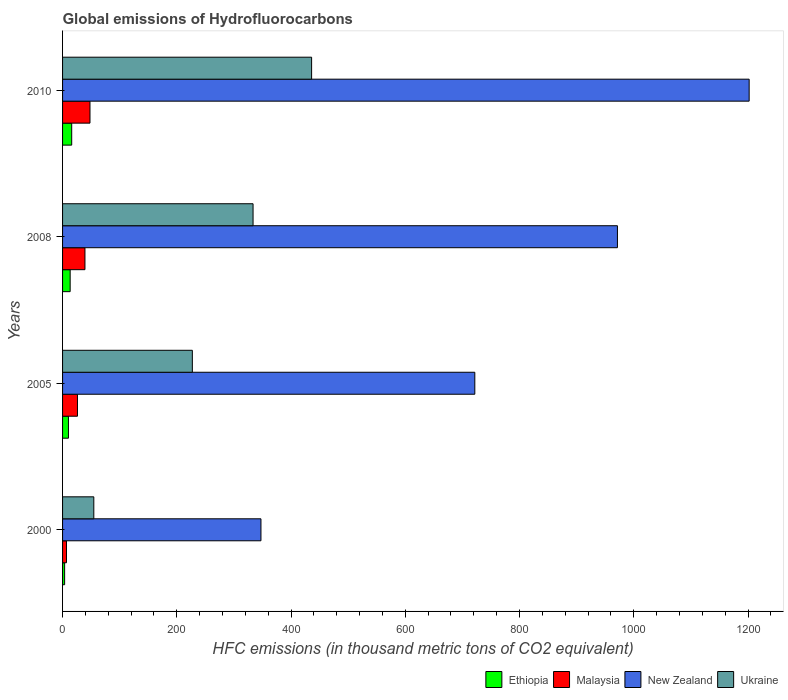How many different coloured bars are there?
Offer a very short reply. 4. Are the number of bars per tick equal to the number of legend labels?
Your answer should be compact. Yes. Are the number of bars on each tick of the Y-axis equal?
Provide a succinct answer. Yes. How many bars are there on the 4th tick from the bottom?
Keep it short and to the point. 4. In which year was the global emissions of Hydrofluorocarbons in Malaysia maximum?
Provide a short and direct response. 2010. In which year was the global emissions of Hydrofluorocarbons in Ethiopia minimum?
Give a very brief answer. 2000. What is the total global emissions of Hydrofluorocarbons in Ethiopia in the graph?
Your answer should be very brief. 43.2. What is the difference between the global emissions of Hydrofluorocarbons in Ukraine in 2005 and that in 2010?
Keep it short and to the point. -208.8. What is the difference between the global emissions of Hydrofluorocarbons in Ukraine in 2010 and the global emissions of Hydrofluorocarbons in Malaysia in 2000?
Provide a short and direct response. 429.1. What is the average global emissions of Hydrofluorocarbons in New Zealand per year?
Your answer should be very brief. 810.6. In the year 2000, what is the difference between the global emissions of Hydrofluorocarbons in Ethiopia and global emissions of Hydrofluorocarbons in New Zealand?
Make the answer very short. -343.7. In how many years, is the global emissions of Hydrofluorocarbons in Ethiopia greater than 920 thousand metric tons?
Make the answer very short. 0. What is the ratio of the global emissions of Hydrofluorocarbons in New Zealand in 2008 to that in 2010?
Offer a terse response. 0.81. Is the difference between the global emissions of Hydrofluorocarbons in Ethiopia in 2005 and 2010 greater than the difference between the global emissions of Hydrofluorocarbons in New Zealand in 2005 and 2010?
Keep it short and to the point. Yes. What is the difference between the highest and the second highest global emissions of Hydrofluorocarbons in Ethiopia?
Keep it short and to the point. 2.7. In how many years, is the global emissions of Hydrofluorocarbons in New Zealand greater than the average global emissions of Hydrofluorocarbons in New Zealand taken over all years?
Your answer should be compact. 2. Is the sum of the global emissions of Hydrofluorocarbons in Ethiopia in 2008 and 2010 greater than the maximum global emissions of Hydrofluorocarbons in New Zealand across all years?
Give a very brief answer. No. What does the 3rd bar from the top in 2008 represents?
Offer a terse response. Malaysia. What does the 3rd bar from the bottom in 2000 represents?
Your response must be concise. New Zealand. How many bars are there?
Your answer should be very brief. 16. Are all the bars in the graph horizontal?
Ensure brevity in your answer.  Yes. Does the graph contain any zero values?
Provide a short and direct response. No. Where does the legend appear in the graph?
Ensure brevity in your answer.  Bottom right. What is the title of the graph?
Provide a succinct answer. Global emissions of Hydrofluorocarbons. What is the label or title of the X-axis?
Keep it short and to the point. HFC emissions (in thousand metric tons of CO2 equivalent). What is the label or title of the Y-axis?
Provide a succinct answer. Years. What is the HFC emissions (in thousand metric tons of CO2 equivalent) of New Zealand in 2000?
Give a very brief answer. 347.3. What is the HFC emissions (in thousand metric tons of CO2 equivalent) of Ukraine in 2000?
Make the answer very short. 54.7. What is the HFC emissions (in thousand metric tons of CO2 equivalent) of Malaysia in 2005?
Make the answer very short. 26.1. What is the HFC emissions (in thousand metric tons of CO2 equivalent) of New Zealand in 2005?
Give a very brief answer. 721.7. What is the HFC emissions (in thousand metric tons of CO2 equivalent) of Ukraine in 2005?
Give a very brief answer. 227.2. What is the HFC emissions (in thousand metric tons of CO2 equivalent) in Ethiopia in 2008?
Make the answer very short. 13.3. What is the HFC emissions (in thousand metric tons of CO2 equivalent) of Malaysia in 2008?
Provide a succinct answer. 39.2. What is the HFC emissions (in thousand metric tons of CO2 equivalent) in New Zealand in 2008?
Make the answer very short. 971.4. What is the HFC emissions (in thousand metric tons of CO2 equivalent) in Ukraine in 2008?
Your answer should be compact. 333.5. What is the HFC emissions (in thousand metric tons of CO2 equivalent) of Ethiopia in 2010?
Ensure brevity in your answer.  16. What is the HFC emissions (in thousand metric tons of CO2 equivalent) in Malaysia in 2010?
Give a very brief answer. 48. What is the HFC emissions (in thousand metric tons of CO2 equivalent) in New Zealand in 2010?
Your answer should be compact. 1202. What is the HFC emissions (in thousand metric tons of CO2 equivalent) of Ukraine in 2010?
Keep it short and to the point. 436. Across all years, what is the maximum HFC emissions (in thousand metric tons of CO2 equivalent) in Ethiopia?
Offer a very short reply. 16. Across all years, what is the maximum HFC emissions (in thousand metric tons of CO2 equivalent) of New Zealand?
Your answer should be compact. 1202. Across all years, what is the maximum HFC emissions (in thousand metric tons of CO2 equivalent) of Ukraine?
Your answer should be compact. 436. Across all years, what is the minimum HFC emissions (in thousand metric tons of CO2 equivalent) in Ethiopia?
Give a very brief answer. 3.6. Across all years, what is the minimum HFC emissions (in thousand metric tons of CO2 equivalent) of New Zealand?
Offer a very short reply. 347.3. Across all years, what is the minimum HFC emissions (in thousand metric tons of CO2 equivalent) in Ukraine?
Ensure brevity in your answer.  54.7. What is the total HFC emissions (in thousand metric tons of CO2 equivalent) in Ethiopia in the graph?
Your answer should be very brief. 43.2. What is the total HFC emissions (in thousand metric tons of CO2 equivalent) in Malaysia in the graph?
Provide a succinct answer. 120.2. What is the total HFC emissions (in thousand metric tons of CO2 equivalent) in New Zealand in the graph?
Provide a succinct answer. 3242.4. What is the total HFC emissions (in thousand metric tons of CO2 equivalent) in Ukraine in the graph?
Provide a short and direct response. 1051.4. What is the difference between the HFC emissions (in thousand metric tons of CO2 equivalent) in Ethiopia in 2000 and that in 2005?
Provide a short and direct response. -6.7. What is the difference between the HFC emissions (in thousand metric tons of CO2 equivalent) of Malaysia in 2000 and that in 2005?
Keep it short and to the point. -19.2. What is the difference between the HFC emissions (in thousand metric tons of CO2 equivalent) of New Zealand in 2000 and that in 2005?
Keep it short and to the point. -374.4. What is the difference between the HFC emissions (in thousand metric tons of CO2 equivalent) in Ukraine in 2000 and that in 2005?
Give a very brief answer. -172.5. What is the difference between the HFC emissions (in thousand metric tons of CO2 equivalent) of Malaysia in 2000 and that in 2008?
Offer a very short reply. -32.3. What is the difference between the HFC emissions (in thousand metric tons of CO2 equivalent) in New Zealand in 2000 and that in 2008?
Provide a short and direct response. -624.1. What is the difference between the HFC emissions (in thousand metric tons of CO2 equivalent) of Ukraine in 2000 and that in 2008?
Provide a short and direct response. -278.8. What is the difference between the HFC emissions (in thousand metric tons of CO2 equivalent) in Ethiopia in 2000 and that in 2010?
Keep it short and to the point. -12.4. What is the difference between the HFC emissions (in thousand metric tons of CO2 equivalent) in Malaysia in 2000 and that in 2010?
Ensure brevity in your answer.  -41.1. What is the difference between the HFC emissions (in thousand metric tons of CO2 equivalent) in New Zealand in 2000 and that in 2010?
Provide a succinct answer. -854.7. What is the difference between the HFC emissions (in thousand metric tons of CO2 equivalent) of Ukraine in 2000 and that in 2010?
Provide a succinct answer. -381.3. What is the difference between the HFC emissions (in thousand metric tons of CO2 equivalent) in Ethiopia in 2005 and that in 2008?
Ensure brevity in your answer.  -3. What is the difference between the HFC emissions (in thousand metric tons of CO2 equivalent) in New Zealand in 2005 and that in 2008?
Your response must be concise. -249.7. What is the difference between the HFC emissions (in thousand metric tons of CO2 equivalent) in Ukraine in 2005 and that in 2008?
Offer a very short reply. -106.3. What is the difference between the HFC emissions (in thousand metric tons of CO2 equivalent) in Ethiopia in 2005 and that in 2010?
Your response must be concise. -5.7. What is the difference between the HFC emissions (in thousand metric tons of CO2 equivalent) in Malaysia in 2005 and that in 2010?
Keep it short and to the point. -21.9. What is the difference between the HFC emissions (in thousand metric tons of CO2 equivalent) in New Zealand in 2005 and that in 2010?
Keep it short and to the point. -480.3. What is the difference between the HFC emissions (in thousand metric tons of CO2 equivalent) in Ukraine in 2005 and that in 2010?
Keep it short and to the point. -208.8. What is the difference between the HFC emissions (in thousand metric tons of CO2 equivalent) of Malaysia in 2008 and that in 2010?
Your answer should be very brief. -8.8. What is the difference between the HFC emissions (in thousand metric tons of CO2 equivalent) of New Zealand in 2008 and that in 2010?
Ensure brevity in your answer.  -230.6. What is the difference between the HFC emissions (in thousand metric tons of CO2 equivalent) in Ukraine in 2008 and that in 2010?
Give a very brief answer. -102.5. What is the difference between the HFC emissions (in thousand metric tons of CO2 equivalent) of Ethiopia in 2000 and the HFC emissions (in thousand metric tons of CO2 equivalent) of Malaysia in 2005?
Your answer should be very brief. -22.5. What is the difference between the HFC emissions (in thousand metric tons of CO2 equivalent) of Ethiopia in 2000 and the HFC emissions (in thousand metric tons of CO2 equivalent) of New Zealand in 2005?
Provide a short and direct response. -718.1. What is the difference between the HFC emissions (in thousand metric tons of CO2 equivalent) in Ethiopia in 2000 and the HFC emissions (in thousand metric tons of CO2 equivalent) in Ukraine in 2005?
Ensure brevity in your answer.  -223.6. What is the difference between the HFC emissions (in thousand metric tons of CO2 equivalent) of Malaysia in 2000 and the HFC emissions (in thousand metric tons of CO2 equivalent) of New Zealand in 2005?
Provide a short and direct response. -714.8. What is the difference between the HFC emissions (in thousand metric tons of CO2 equivalent) in Malaysia in 2000 and the HFC emissions (in thousand metric tons of CO2 equivalent) in Ukraine in 2005?
Provide a short and direct response. -220.3. What is the difference between the HFC emissions (in thousand metric tons of CO2 equivalent) of New Zealand in 2000 and the HFC emissions (in thousand metric tons of CO2 equivalent) of Ukraine in 2005?
Provide a short and direct response. 120.1. What is the difference between the HFC emissions (in thousand metric tons of CO2 equivalent) in Ethiopia in 2000 and the HFC emissions (in thousand metric tons of CO2 equivalent) in Malaysia in 2008?
Keep it short and to the point. -35.6. What is the difference between the HFC emissions (in thousand metric tons of CO2 equivalent) of Ethiopia in 2000 and the HFC emissions (in thousand metric tons of CO2 equivalent) of New Zealand in 2008?
Make the answer very short. -967.8. What is the difference between the HFC emissions (in thousand metric tons of CO2 equivalent) in Ethiopia in 2000 and the HFC emissions (in thousand metric tons of CO2 equivalent) in Ukraine in 2008?
Provide a short and direct response. -329.9. What is the difference between the HFC emissions (in thousand metric tons of CO2 equivalent) of Malaysia in 2000 and the HFC emissions (in thousand metric tons of CO2 equivalent) of New Zealand in 2008?
Your answer should be very brief. -964.5. What is the difference between the HFC emissions (in thousand metric tons of CO2 equivalent) of Malaysia in 2000 and the HFC emissions (in thousand metric tons of CO2 equivalent) of Ukraine in 2008?
Provide a short and direct response. -326.6. What is the difference between the HFC emissions (in thousand metric tons of CO2 equivalent) in Ethiopia in 2000 and the HFC emissions (in thousand metric tons of CO2 equivalent) in Malaysia in 2010?
Ensure brevity in your answer.  -44.4. What is the difference between the HFC emissions (in thousand metric tons of CO2 equivalent) of Ethiopia in 2000 and the HFC emissions (in thousand metric tons of CO2 equivalent) of New Zealand in 2010?
Provide a short and direct response. -1198.4. What is the difference between the HFC emissions (in thousand metric tons of CO2 equivalent) in Ethiopia in 2000 and the HFC emissions (in thousand metric tons of CO2 equivalent) in Ukraine in 2010?
Your answer should be compact. -432.4. What is the difference between the HFC emissions (in thousand metric tons of CO2 equivalent) of Malaysia in 2000 and the HFC emissions (in thousand metric tons of CO2 equivalent) of New Zealand in 2010?
Ensure brevity in your answer.  -1195.1. What is the difference between the HFC emissions (in thousand metric tons of CO2 equivalent) of Malaysia in 2000 and the HFC emissions (in thousand metric tons of CO2 equivalent) of Ukraine in 2010?
Ensure brevity in your answer.  -429.1. What is the difference between the HFC emissions (in thousand metric tons of CO2 equivalent) in New Zealand in 2000 and the HFC emissions (in thousand metric tons of CO2 equivalent) in Ukraine in 2010?
Provide a succinct answer. -88.7. What is the difference between the HFC emissions (in thousand metric tons of CO2 equivalent) in Ethiopia in 2005 and the HFC emissions (in thousand metric tons of CO2 equivalent) in Malaysia in 2008?
Provide a succinct answer. -28.9. What is the difference between the HFC emissions (in thousand metric tons of CO2 equivalent) of Ethiopia in 2005 and the HFC emissions (in thousand metric tons of CO2 equivalent) of New Zealand in 2008?
Offer a very short reply. -961.1. What is the difference between the HFC emissions (in thousand metric tons of CO2 equivalent) of Ethiopia in 2005 and the HFC emissions (in thousand metric tons of CO2 equivalent) of Ukraine in 2008?
Your answer should be very brief. -323.2. What is the difference between the HFC emissions (in thousand metric tons of CO2 equivalent) in Malaysia in 2005 and the HFC emissions (in thousand metric tons of CO2 equivalent) in New Zealand in 2008?
Provide a short and direct response. -945.3. What is the difference between the HFC emissions (in thousand metric tons of CO2 equivalent) of Malaysia in 2005 and the HFC emissions (in thousand metric tons of CO2 equivalent) of Ukraine in 2008?
Give a very brief answer. -307.4. What is the difference between the HFC emissions (in thousand metric tons of CO2 equivalent) of New Zealand in 2005 and the HFC emissions (in thousand metric tons of CO2 equivalent) of Ukraine in 2008?
Your answer should be very brief. 388.2. What is the difference between the HFC emissions (in thousand metric tons of CO2 equivalent) in Ethiopia in 2005 and the HFC emissions (in thousand metric tons of CO2 equivalent) in Malaysia in 2010?
Keep it short and to the point. -37.7. What is the difference between the HFC emissions (in thousand metric tons of CO2 equivalent) in Ethiopia in 2005 and the HFC emissions (in thousand metric tons of CO2 equivalent) in New Zealand in 2010?
Your answer should be compact. -1191.7. What is the difference between the HFC emissions (in thousand metric tons of CO2 equivalent) of Ethiopia in 2005 and the HFC emissions (in thousand metric tons of CO2 equivalent) of Ukraine in 2010?
Keep it short and to the point. -425.7. What is the difference between the HFC emissions (in thousand metric tons of CO2 equivalent) of Malaysia in 2005 and the HFC emissions (in thousand metric tons of CO2 equivalent) of New Zealand in 2010?
Your answer should be compact. -1175.9. What is the difference between the HFC emissions (in thousand metric tons of CO2 equivalent) in Malaysia in 2005 and the HFC emissions (in thousand metric tons of CO2 equivalent) in Ukraine in 2010?
Your answer should be very brief. -409.9. What is the difference between the HFC emissions (in thousand metric tons of CO2 equivalent) in New Zealand in 2005 and the HFC emissions (in thousand metric tons of CO2 equivalent) in Ukraine in 2010?
Ensure brevity in your answer.  285.7. What is the difference between the HFC emissions (in thousand metric tons of CO2 equivalent) in Ethiopia in 2008 and the HFC emissions (in thousand metric tons of CO2 equivalent) in Malaysia in 2010?
Your answer should be very brief. -34.7. What is the difference between the HFC emissions (in thousand metric tons of CO2 equivalent) in Ethiopia in 2008 and the HFC emissions (in thousand metric tons of CO2 equivalent) in New Zealand in 2010?
Offer a very short reply. -1188.7. What is the difference between the HFC emissions (in thousand metric tons of CO2 equivalent) of Ethiopia in 2008 and the HFC emissions (in thousand metric tons of CO2 equivalent) of Ukraine in 2010?
Your answer should be very brief. -422.7. What is the difference between the HFC emissions (in thousand metric tons of CO2 equivalent) in Malaysia in 2008 and the HFC emissions (in thousand metric tons of CO2 equivalent) in New Zealand in 2010?
Offer a very short reply. -1162.8. What is the difference between the HFC emissions (in thousand metric tons of CO2 equivalent) of Malaysia in 2008 and the HFC emissions (in thousand metric tons of CO2 equivalent) of Ukraine in 2010?
Your answer should be very brief. -396.8. What is the difference between the HFC emissions (in thousand metric tons of CO2 equivalent) in New Zealand in 2008 and the HFC emissions (in thousand metric tons of CO2 equivalent) in Ukraine in 2010?
Your answer should be compact. 535.4. What is the average HFC emissions (in thousand metric tons of CO2 equivalent) of Ethiopia per year?
Your answer should be very brief. 10.8. What is the average HFC emissions (in thousand metric tons of CO2 equivalent) of Malaysia per year?
Provide a succinct answer. 30.05. What is the average HFC emissions (in thousand metric tons of CO2 equivalent) of New Zealand per year?
Keep it short and to the point. 810.6. What is the average HFC emissions (in thousand metric tons of CO2 equivalent) of Ukraine per year?
Give a very brief answer. 262.85. In the year 2000, what is the difference between the HFC emissions (in thousand metric tons of CO2 equivalent) in Ethiopia and HFC emissions (in thousand metric tons of CO2 equivalent) in Malaysia?
Keep it short and to the point. -3.3. In the year 2000, what is the difference between the HFC emissions (in thousand metric tons of CO2 equivalent) of Ethiopia and HFC emissions (in thousand metric tons of CO2 equivalent) of New Zealand?
Your response must be concise. -343.7. In the year 2000, what is the difference between the HFC emissions (in thousand metric tons of CO2 equivalent) in Ethiopia and HFC emissions (in thousand metric tons of CO2 equivalent) in Ukraine?
Keep it short and to the point. -51.1. In the year 2000, what is the difference between the HFC emissions (in thousand metric tons of CO2 equivalent) in Malaysia and HFC emissions (in thousand metric tons of CO2 equivalent) in New Zealand?
Your answer should be compact. -340.4. In the year 2000, what is the difference between the HFC emissions (in thousand metric tons of CO2 equivalent) of Malaysia and HFC emissions (in thousand metric tons of CO2 equivalent) of Ukraine?
Give a very brief answer. -47.8. In the year 2000, what is the difference between the HFC emissions (in thousand metric tons of CO2 equivalent) of New Zealand and HFC emissions (in thousand metric tons of CO2 equivalent) of Ukraine?
Offer a terse response. 292.6. In the year 2005, what is the difference between the HFC emissions (in thousand metric tons of CO2 equivalent) in Ethiopia and HFC emissions (in thousand metric tons of CO2 equivalent) in Malaysia?
Your answer should be compact. -15.8. In the year 2005, what is the difference between the HFC emissions (in thousand metric tons of CO2 equivalent) in Ethiopia and HFC emissions (in thousand metric tons of CO2 equivalent) in New Zealand?
Provide a short and direct response. -711.4. In the year 2005, what is the difference between the HFC emissions (in thousand metric tons of CO2 equivalent) in Ethiopia and HFC emissions (in thousand metric tons of CO2 equivalent) in Ukraine?
Provide a succinct answer. -216.9. In the year 2005, what is the difference between the HFC emissions (in thousand metric tons of CO2 equivalent) of Malaysia and HFC emissions (in thousand metric tons of CO2 equivalent) of New Zealand?
Your answer should be very brief. -695.6. In the year 2005, what is the difference between the HFC emissions (in thousand metric tons of CO2 equivalent) of Malaysia and HFC emissions (in thousand metric tons of CO2 equivalent) of Ukraine?
Keep it short and to the point. -201.1. In the year 2005, what is the difference between the HFC emissions (in thousand metric tons of CO2 equivalent) of New Zealand and HFC emissions (in thousand metric tons of CO2 equivalent) of Ukraine?
Provide a short and direct response. 494.5. In the year 2008, what is the difference between the HFC emissions (in thousand metric tons of CO2 equivalent) in Ethiopia and HFC emissions (in thousand metric tons of CO2 equivalent) in Malaysia?
Offer a terse response. -25.9. In the year 2008, what is the difference between the HFC emissions (in thousand metric tons of CO2 equivalent) in Ethiopia and HFC emissions (in thousand metric tons of CO2 equivalent) in New Zealand?
Your response must be concise. -958.1. In the year 2008, what is the difference between the HFC emissions (in thousand metric tons of CO2 equivalent) of Ethiopia and HFC emissions (in thousand metric tons of CO2 equivalent) of Ukraine?
Give a very brief answer. -320.2. In the year 2008, what is the difference between the HFC emissions (in thousand metric tons of CO2 equivalent) in Malaysia and HFC emissions (in thousand metric tons of CO2 equivalent) in New Zealand?
Offer a very short reply. -932.2. In the year 2008, what is the difference between the HFC emissions (in thousand metric tons of CO2 equivalent) of Malaysia and HFC emissions (in thousand metric tons of CO2 equivalent) of Ukraine?
Give a very brief answer. -294.3. In the year 2008, what is the difference between the HFC emissions (in thousand metric tons of CO2 equivalent) in New Zealand and HFC emissions (in thousand metric tons of CO2 equivalent) in Ukraine?
Offer a very short reply. 637.9. In the year 2010, what is the difference between the HFC emissions (in thousand metric tons of CO2 equivalent) of Ethiopia and HFC emissions (in thousand metric tons of CO2 equivalent) of Malaysia?
Offer a very short reply. -32. In the year 2010, what is the difference between the HFC emissions (in thousand metric tons of CO2 equivalent) of Ethiopia and HFC emissions (in thousand metric tons of CO2 equivalent) of New Zealand?
Your answer should be compact. -1186. In the year 2010, what is the difference between the HFC emissions (in thousand metric tons of CO2 equivalent) of Ethiopia and HFC emissions (in thousand metric tons of CO2 equivalent) of Ukraine?
Offer a very short reply. -420. In the year 2010, what is the difference between the HFC emissions (in thousand metric tons of CO2 equivalent) of Malaysia and HFC emissions (in thousand metric tons of CO2 equivalent) of New Zealand?
Provide a succinct answer. -1154. In the year 2010, what is the difference between the HFC emissions (in thousand metric tons of CO2 equivalent) in Malaysia and HFC emissions (in thousand metric tons of CO2 equivalent) in Ukraine?
Give a very brief answer. -388. In the year 2010, what is the difference between the HFC emissions (in thousand metric tons of CO2 equivalent) in New Zealand and HFC emissions (in thousand metric tons of CO2 equivalent) in Ukraine?
Make the answer very short. 766. What is the ratio of the HFC emissions (in thousand metric tons of CO2 equivalent) of Ethiopia in 2000 to that in 2005?
Give a very brief answer. 0.35. What is the ratio of the HFC emissions (in thousand metric tons of CO2 equivalent) of Malaysia in 2000 to that in 2005?
Your response must be concise. 0.26. What is the ratio of the HFC emissions (in thousand metric tons of CO2 equivalent) of New Zealand in 2000 to that in 2005?
Keep it short and to the point. 0.48. What is the ratio of the HFC emissions (in thousand metric tons of CO2 equivalent) of Ukraine in 2000 to that in 2005?
Your response must be concise. 0.24. What is the ratio of the HFC emissions (in thousand metric tons of CO2 equivalent) in Ethiopia in 2000 to that in 2008?
Ensure brevity in your answer.  0.27. What is the ratio of the HFC emissions (in thousand metric tons of CO2 equivalent) of Malaysia in 2000 to that in 2008?
Your answer should be very brief. 0.18. What is the ratio of the HFC emissions (in thousand metric tons of CO2 equivalent) in New Zealand in 2000 to that in 2008?
Offer a very short reply. 0.36. What is the ratio of the HFC emissions (in thousand metric tons of CO2 equivalent) in Ukraine in 2000 to that in 2008?
Offer a terse response. 0.16. What is the ratio of the HFC emissions (in thousand metric tons of CO2 equivalent) in Ethiopia in 2000 to that in 2010?
Ensure brevity in your answer.  0.23. What is the ratio of the HFC emissions (in thousand metric tons of CO2 equivalent) in Malaysia in 2000 to that in 2010?
Ensure brevity in your answer.  0.14. What is the ratio of the HFC emissions (in thousand metric tons of CO2 equivalent) of New Zealand in 2000 to that in 2010?
Offer a terse response. 0.29. What is the ratio of the HFC emissions (in thousand metric tons of CO2 equivalent) in Ukraine in 2000 to that in 2010?
Give a very brief answer. 0.13. What is the ratio of the HFC emissions (in thousand metric tons of CO2 equivalent) of Ethiopia in 2005 to that in 2008?
Offer a terse response. 0.77. What is the ratio of the HFC emissions (in thousand metric tons of CO2 equivalent) of Malaysia in 2005 to that in 2008?
Offer a terse response. 0.67. What is the ratio of the HFC emissions (in thousand metric tons of CO2 equivalent) of New Zealand in 2005 to that in 2008?
Make the answer very short. 0.74. What is the ratio of the HFC emissions (in thousand metric tons of CO2 equivalent) in Ukraine in 2005 to that in 2008?
Provide a short and direct response. 0.68. What is the ratio of the HFC emissions (in thousand metric tons of CO2 equivalent) in Ethiopia in 2005 to that in 2010?
Provide a succinct answer. 0.64. What is the ratio of the HFC emissions (in thousand metric tons of CO2 equivalent) of Malaysia in 2005 to that in 2010?
Ensure brevity in your answer.  0.54. What is the ratio of the HFC emissions (in thousand metric tons of CO2 equivalent) in New Zealand in 2005 to that in 2010?
Your response must be concise. 0.6. What is the ratio of the HFC emissions (in thousand metric tons of CO2 equivalent) in Ukraine in 2005 to that in 2010?
Provide a short and direct response. 0.52. What is the ratio of the HFC emissions (in thousand metric tons of CO2 equivalent) in Ethiopia in 2008 to that in 2010?
Your answer should be very brief. 0.83. What is the ratio of the HFC emissions (in thousand metric tons of CO2 equivalent) in Malaysia in 2008 to that in 2010?
Your answer should be compact. 0.82. What is the ratio of the HFC emissions (in thousand metric tons of CO2 equivalent) of New Zealand in 2008 to that in 2010?
Make the answer very short. 0.81. What is the ratio of the HFC emissions (in thousand metric tons of CO2 equivalent) of Ukraine in 2008 to that in 2010?
Your response must be concise. 0.76. What is the difference between the highest and the second highest HFC emissions (in thousand metric tons of CO2 equivalent) in Ethiopia?
Your answer should be compact. 2.7. What is the difference between the highest and the second highest HFC emissions (in thousand metric tons of CO2 equivalent) in New Zealand?
Your response must be concise. 230.6. What is the difference between the highest and the second highest HFC emissions (in thousand metric tons of CO2 equivalent) in Ukraine?
Offer a terse response. 102.5. What is the difference between the highest and the lowest HFC emissions (in thousand metric tons of CO2 equivalent) of Malaysia?
Ensure brevity in your answer.  41.1. What is the difference between the highest and the lowest HFC emissions (in thousand metric tons of CO2 equivalent) in New Zealand?
Keep it short and to the point. 854.7. What is the difference between the highest and the lowest HFC emissions (in thousand metric tons of CO2 equivalent) in Ukraine?
Make the answer very short. 381.3. 